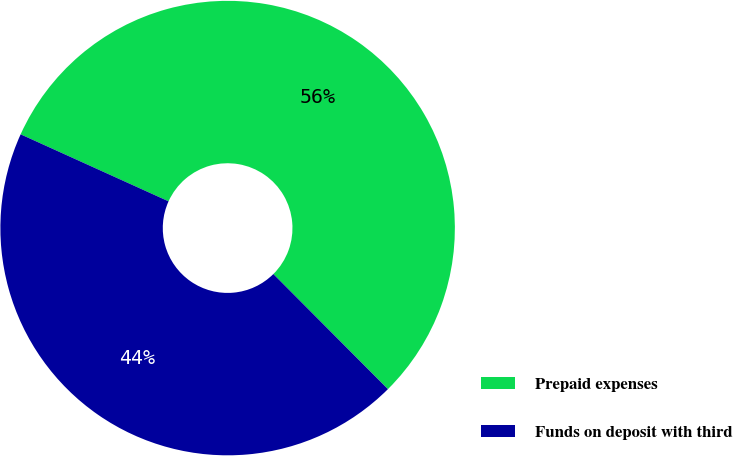Convert chart to OTSL. <chart><loc_0><loc_0><loc_500><loc_500><pie_chart><fcel>Prepaid expenses<fcel>Funds on deposit with third<nl><fcel>55.77%<fcel>44.23%<nl></chart> 